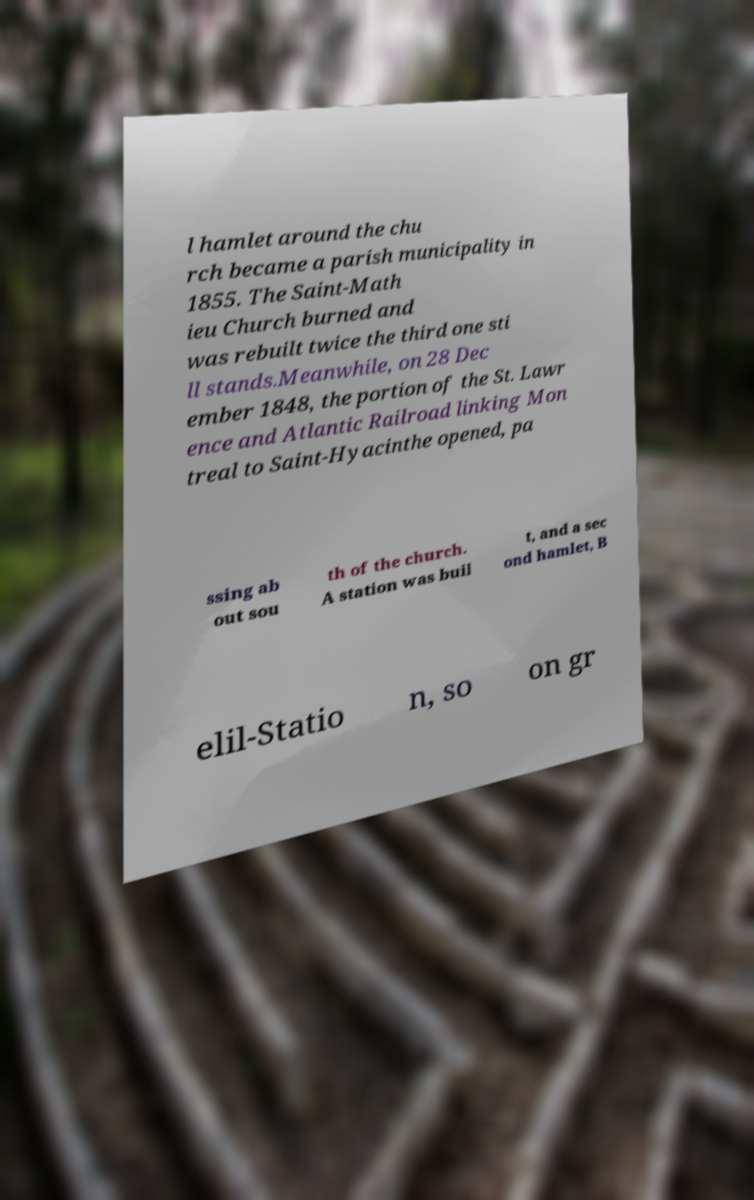I need the written content from this picture converted into text. Can you do that? l hamlet around the chu rch became a parish municipality in 1855. The Saint-Math ieu Church burned and was rebuilt twice the third one sti ll stands.Meanwhile, on 28 Dec ember 1848, the portion of the St. Lawr ence and Atlantic Railroad linking Mon treal to Saint-Hyacinthe opened, pa ssing ab out sou th of the church. A station was buil t, and a sec ond hamlet, B elil-Statio n, so on gr 